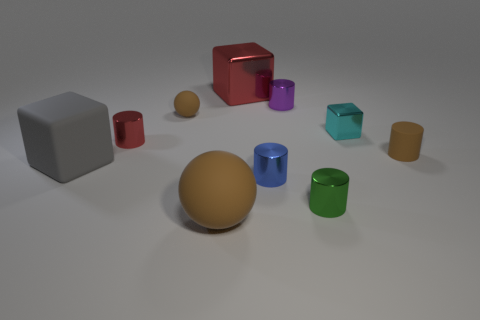Subtract all green cylinders. How many cylinders are left? 4 Subtract 1 cylinders. How many cylinders are left? 4 Subtract all brown cylinders. How many cylinders are left? 4 Subtract all blocks. How many objects are left? 7 Subtract all cyan objects. Subtract all small purple metal objects. How many objects are left? 8 Add 8 big gray matte blocks. How many big gray matte blocks are left? 9 Add 6 tiny metal cylinders. How many tiny metal cylinders exist? 10 Subtract 1 blue cylinders. How many objects are left? 9 Subtract all red cylinders. Subtract all purple spheres. How many cylinders are left? 4 